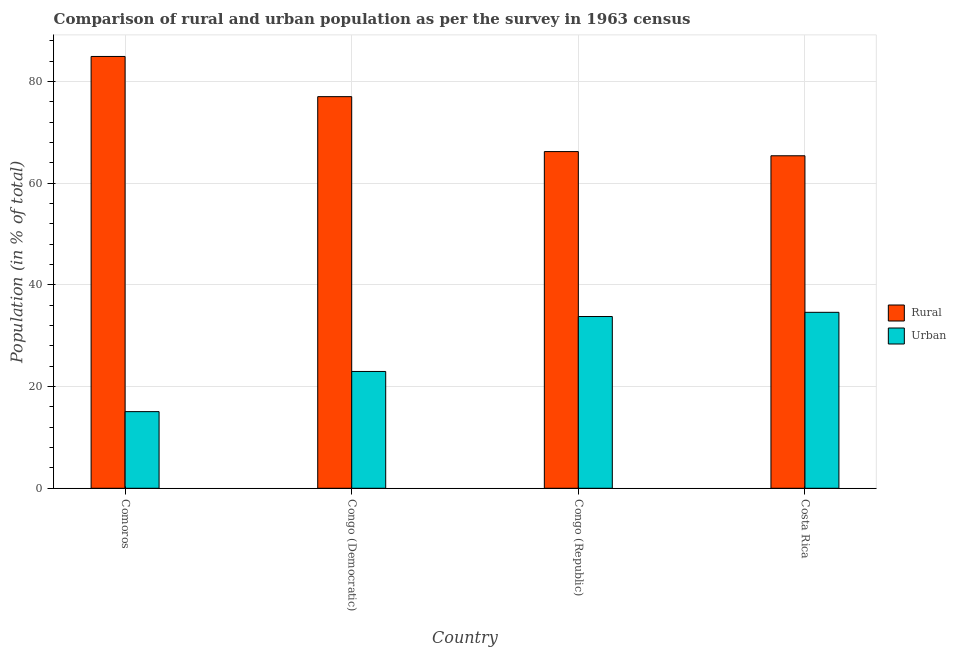How many different coloured bars are there?
Make the answer very short. 2. Are the number of bars per tick equal to the number of legend labels?
Offer a very short reply. Yes. Are the number of bars on each tick of the X-axis equal?
Make the answer very short. Yes. How many bars are there on the 4th tick from the left?
Ensure brevity in your answer.  2. What is the label of the 2nd group of bars from the left?
Give a very brief answer. Congo (Democratic). What is the urban population in Congo (Democratic)?
Keep it short and to the point. 22.98. Across all countries, what is the maximum rural population?
Make the answer very short. 84.93. Across all countries, what is the minimum rural population?
Offer a terse response. 65.39. In which country was the rural population maximum?
Provide a succinct answer. Comoros. In which country was the rural population minimum?
Your answer should be compact. Costa Rica. What is the total rural population in the graph?
Your response must be concise. 293.56. What is the difference between the urban population in Congo (Republic) and that in Costa Rica?
Your answer should be compact. -0.83. What is the difference between the rural population in Congo (Republic) and the urban population in Congo (Democratic)?
Offer a terse response. 43.24. What is the average rural population per country?
Offer a terse response. 73.39. What is the difference between the rural population and urban population in Congo (Democratic)?
Give a very brief answer. 54.05. What is the ratio of the urban population in Congo (Democratic) to that in Congo (Republic)?
Your answer should be very brief. 0.68. What is the difference between the highest and the second highest rural population?
Offer a terse response. 7.9. What is the difference between the highest and the lowest urban population?
Your answer should be compact. 19.53. In how many countries, is the rural population greater than the average rural population taken over all countries?
Provide a short and direct response. 2. What does the 1st bar from the left in Congo (Republic) represents?
Give a very brief answer. Rural. What does the 2nd bar from the right in Costa Rica represents?
Provide a short and direct response. Rural. Are all the bars in the graph horizontal?
Ensure brevity in your answer.  No. What is the difference between two consecutive major ticks on the Y-axis?
Make the answer very short. 20. Are the values on the major ticks of Y-axis written in scientific E-notation?
Offer a very short reply. No. Does the graph contain grids?
Your answer should be compact. Yes. Where does the legend appear in the graph?
Ensure brevity in your answer.  Center right. How many legend labels are there?
Provide a succinct answer. 2. What is the title of the graph?
Your answer should be very brief. Comparison of rural and urban population as per the survey in 1963 census. What is the label or title of the X-axis?
Keep it short and to the point. Country. What is the label or title of the Y-axis?
Provide a succinct answer. Population (in % of total). What is the Population (in % of total) in Rural in Comoros?
Provide a short and direct response. 84.93. What is the Population (in % of total) of Urban in Comoros?
Offer a very short reply. 15.07. What is the Population (in % of total) of Rural in Congo (Democratic)?
Make the answer very short. 77.02. What is the Population (in % of total) in Urban in Congo (Democratic)?
Keep it short and to the point. 22.98. What is the Population (in % of total) of Rural in Congo (Republic)?
Ensure brevity in your answer.  66.22. What is the Population (in % of total) in Urban in Congo (Republic)?
Provide a short and direct response. 33.78. What is the Population (in % of total) in Rural in Costa Rica?
Offer a terse response. 65.39. What is the Population (in % of total) of Urban in Costa Rica?
Provide a short and direct response. 34.61. Across all countries, what is the maximum Population (in % of total) of Rural?
Your answer should be compact. 84.93. Across all countries, what is the maximum Population (in % of total) of Urban?
Give a very brief answer. 34.61. Across all countries, what is the minimum Population (in % of total) of Rural?
Your response must be concise. 65.39. Across all countries, what is the minimum Population (in % of total) of Urban?
Keep it short and to the point. 15.07. What is the total Population (in % of total) in Rural in the graph?
Offer a very short reply. 293.56. What is the total Population (in % of total) of Urban in the graph?
Offer a very short reply. 106.44. What is the difference between the Population (in % of total) in Rural in Comoros and that in Congo (Democratic)?
Your answer should be compact. 7.9. What is the difference between the Population (in % of total) in Urban in Comoros and that in Congo (Democratic)?
Ensure brevity in your answer.  -7.9. What is the difference between the Population (in % of total) of Rural in Comoros and that in Congo (Republic)?
Provide a short and direct response. 18.71. What is the difference between the Population (in % of total) of Urban in Comoros and that in Congo (Republic)?
Make the answer very short. -18.71. What is the difference between the Population (in % of total) in Rural in Comoros and that in Costa Rica?
Offer a terse response. 19.53. What is the difference between the Population (in % of total) of Urban in Comoros and that in Costa Rica?
Provide a succinct answer. -19.53. What is the difference between the Population (in % of total) in Rural in Congo (Democratic) and that in Congo (Republic)?
Offer a terse response. 10.8. What is the difference between the Population (in % of total) of Urban in Congo (Democratic) and that in Congo (Republic)?
Provide a short and direct response. -10.8. What is the difference between the Population (in % of total) of Rural in Congo (Democratic) and that in Costa Rica?
Your answer should be compact. 11.63. What is the difference between the Population (in % of total) in Urban in Congo (Democratic) and that in Costa Rica?
Keep it short and to the point. -11.63. What is the difference between the Population (in % of total) in Rural in Congo (Republic) and that in Costa Rica?
Your response must be concise. 0.83. What is the difference between the Population (in % of total) in Urban in Congo (Republic) and that in Costa Rica?
Provide a succinct answer. -0.83. What is the difference between the Population (in % of total) in Rural in Comoros and the Population (in % of total) in Urban in Congo (Democratic)?
Offer a terse response. 61.95. What is the difference between the Population (in % of total) in Rural in Comoros and the Population (in % of total) in Urban in Congo (Republic)?
Ensure brevity in your answer.  51.15. What is the difference between the Population (in % of total) of Rural in Comoros and the Population (in % of total) of Urban in Costa Rica?
Give a very brief answer. 50.32. What is the difference between the Population (in % of total) of Rural in Congo (Democratic) and the Population (in % of total) of Urban in Congo (Republic)?
Offer a very short reply. 43.24. What is the difference between the Population (in % of total) of Rural in Congo (Democratic) and the Population (in % of total) of Urban in Costa Rica?
Your answer should be very brief. 42.42. What is the difference between the Population (in % of total) of Rural in Congo (Republic) and the Population (in % of total) of Urban in Costa Rica?
Offer a very short reply. 31.61. What is the average Population (in % of total) of Rural per country?
Make the answer very short. 73.39. What is the average Population (in % of total) in Urban per country?
Offer a very short reply. 26.61. What is the difference between the Population (in % of total) in Rural and Population (in % of total) in Urban in Comoros?
Give a very brief answer. 69.85. What is the difference between the Population (in % of total) in Rural and Population (in % of total) in Urban in Congo (Democratic)?
Provide a succinct answer. 54.05. What is the difference between the Population (in % of total) in Rural and Population (in % of total) in Urban in Congo (Republic)?
Offer a terse response. 32.44. What is the difference between the Population (in % of total) of Rural and Population (in % of total) of Urban in Costa Rica?
Give a very brief answer. 30.79. What is the ratio of the Population (in % of total) of Rural in Comoros to that in Congo (Democratic)?
Your response must be concise. 1.1. What is the ratio of the Population (in % of total) of Urban in Comoros to that in Congo (Democratic)?
Ensure brevity in your answer.  0.66. What is the ratio of the Population (in % of total) in Rural in Comoros to that in Congo (Republic)?
Ensure brevity in your answer.  1.28. What is the ratio of the Population (in % of total) in Urban in Comoros to that in Congo (Republic)?
Keep it short and to the point. 0.45. What is the ratio of the Population (in % of total) of Rural in Comoros to that in Costa Rica?
Offer a very short reply. 1.3. What is the ratio of the Population (in % of total) in Urban in Comoros to that in Costa Rica?
Give a very brief answer. 0.44. What is the ratio of the Population (in % of total) in Rural in Congo (Democratic) to that in Congo (Republic)?
Ensure brevity in your answer.  1.16. What is the ratio of the Population (in % of total) in Urban in Congo (Democratic) to that in Congo (Republic)?
Provide a short and direct response. 0.68. What is the ratio of the Population (in % of total) of Rural in Congo (Democratic) to that in Costa Rica?
Your response must be concise. 1.18. What is the ratio of the Population (in % of total) in Urban in Congo (Democratic) to that in Costa Rica?
Your answer should be very brief. 0.66. What is the ratio of the Population (in % of total) of Rural in Congo (Republic) to that in Costa Rica?
Your response must be concise. 1.01. What is the ratio of the Population (in % of total) in Urban in Congo (Republic) to that in Costa Rica?
Keep it short and to the point. 0.98. What is the difference between the highest and the second highest Population (in % of total) in Rural?
Offer a terse response. 7.9. What is the difference between the highest and the second highest Population (in % of total) of Urban?
Make the answer very short. 0.83. What is the difference between the highest and the lowest Population (in % of total) of Rural?
Ensure brevity in your answer.  19.53. What is the difference between the highest and the lowest Population (in % of total) of Urban?
Ensure brevity in your answer.  19.53. 